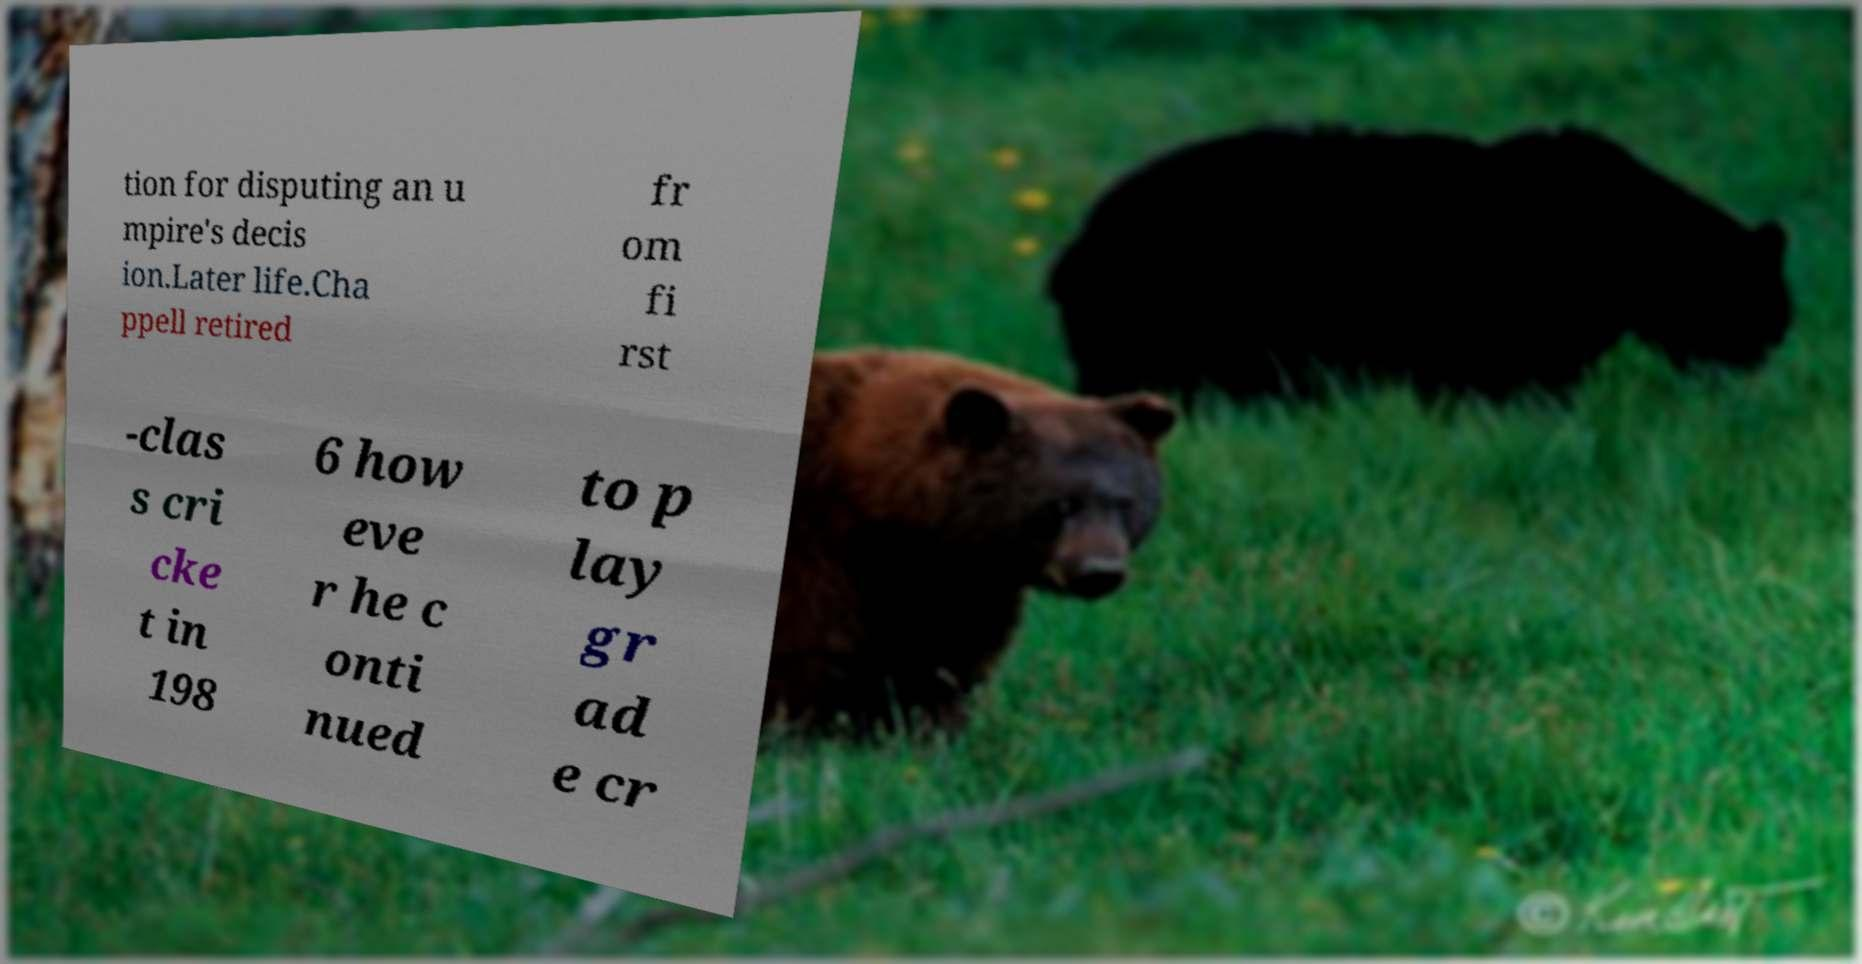There's text embedded in this image that I need extracted. Can you transcribe it verbatim? tion for disputing an u mpire's decis ion.Later life.Cha ppell retired fr om fi rst -clas s cri cke t in 198 6 how eve r he c onti nued to p lay gr ad e cr 